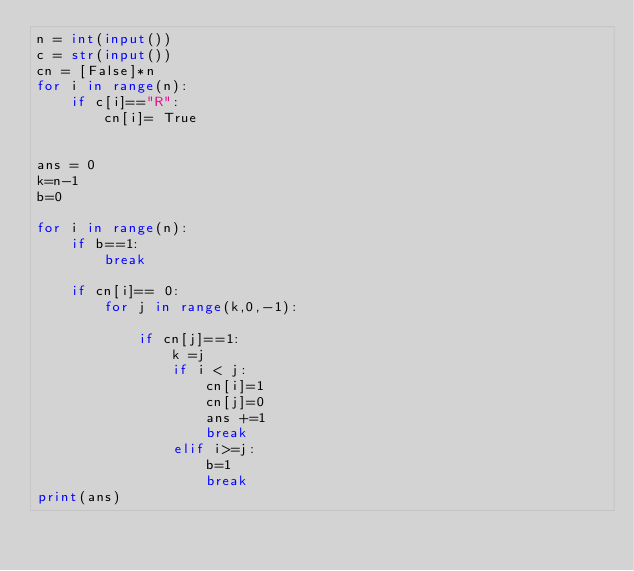Convert code to text. <code><loc_0><loc_0><loc_500><loc_500><_Python_>n = int(input())
c = str(input())
cn = [False]*n
for i in range(n):
    if c[i]=="R":
        cn[i]= True


ans = 0
k=n-1
b=0

for i in range(n):
    if b==1:
        break

    if cn[i]== 0:
        for j in range(k,0,-1):

            if cn[j]==1:
                k =j
                if i < j:
                    cn[i]=1
                    cn[j]=0
                    ans +=1
                    break
                elif i>=j:
                    b=1
                    break
print(ans)</code> 